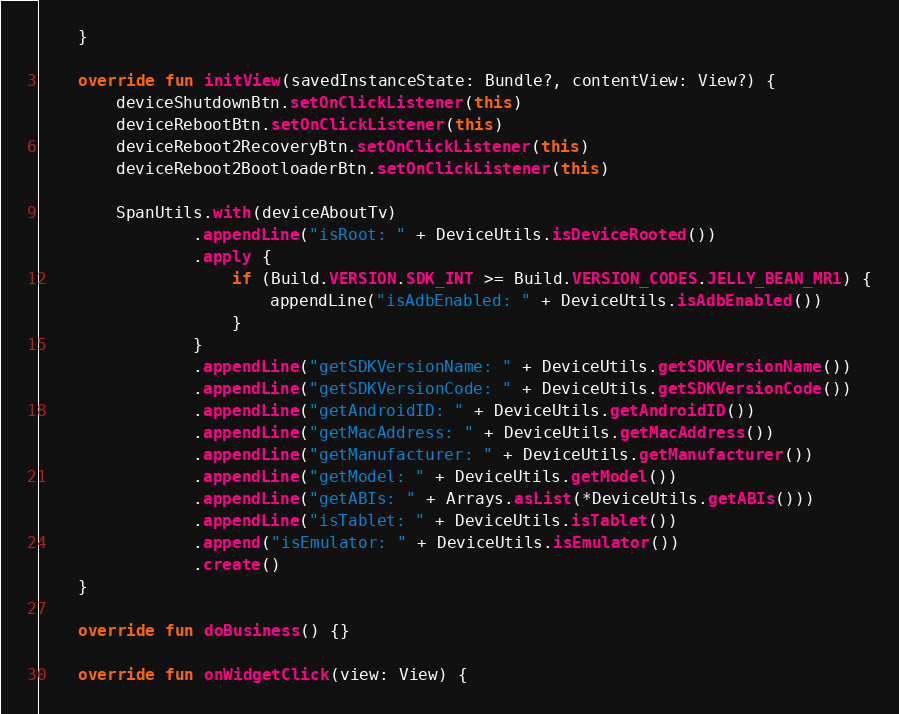Convert code to text. <code><loc_0><loc_0><loc_500><loc_500><_Kotlin_>    }

    override fun initView(savedInstanceState: Bundle?, contentView: View?) {
        deviceShutdownBtn.setOnClickListener(this)
        deviceRebootBtn.setOnClickListener(this)
        deviceReboot2RecoveryBtn.setOnClickListener(this)
        deviceReboot2BootloaderBtn.setOnClickListener(this)

        SpanUtils.with(deviceAboutTv)
                .appendLine("isRoot: " + DeviceUtils.isDeviceRooted())
                .apply {
                    if (Build.VERSION.SDK_INT >= Build.VERSION_CODES.JELLY_BEAN_MR1) {
                        appendLine("isAdbEnabled: " + DeviceUtils.isAdbEnabled())
                    }
                }
                .appendLine("getSDKVersionName: " + DeviceUtils.getSDKVersionName())
                .appendLine("getSDKVersionCode: " + DeviceUtils.getSDKVersionCode())
                .appendLine("getAndroidID: " + DeviceUtils.getAndroidID())
                .appendLine("getMacAddress: " + DeviceUtils.getMacAddress())
                .appendLine("getManufacturer: " + DeviceUtils.getManufacturer())
                .appendLine("getModel: " + DeviceUtils.getModel())
                .appendLine("getABIs: " + Arrays.asList(*DeviceUtils.getABIs()))
                .appendLine("isTablet: " + DeviceUtils.isTablet())
                .append("isEmulator: " + DeviceUtils.isEmulator())
                .create()
    }

    override fun doBusiness() {}

    override fun onWidgetClick(view: View) {</code> 